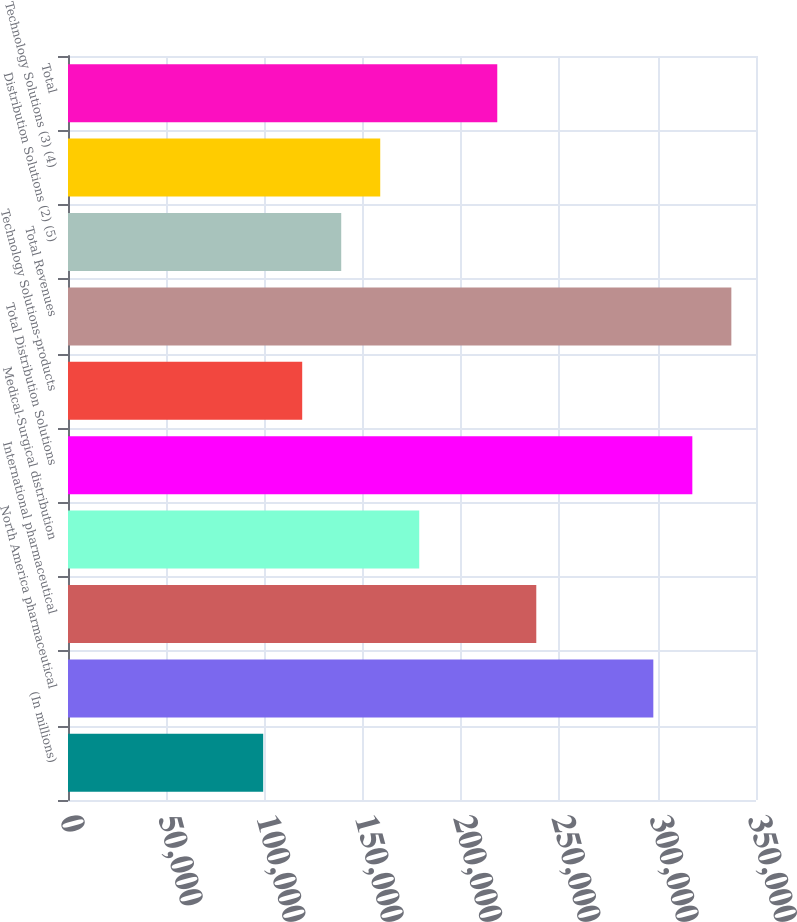Convert chart. <chart><loc_0><loc_0><loc_500><loc_500><bar_chart><fcel>(In millions)<fcel>North America pharmaceutical<fcel>International pharmaceutical<fcel>Medical-Surgical distribution<fcel>Total Distribution Solutions<fcel>Technology Solutions-products<fcel>Total Revenues<fcel>Distribution Solutions (2) (5)<fcel>Technology Solutions (3) (4)<fcel>Total<nl><fcel>99299<fcel>297767<fcel>238227<fcel>178686<fcel>317614<fcel>119146<fcel>337461<fcel>138993<fcel>158839<fcel>218380<nl></chart> 